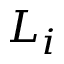<formula> <loc_0><loc_0><loc_500><loc_500>L _ { i }</formula> 